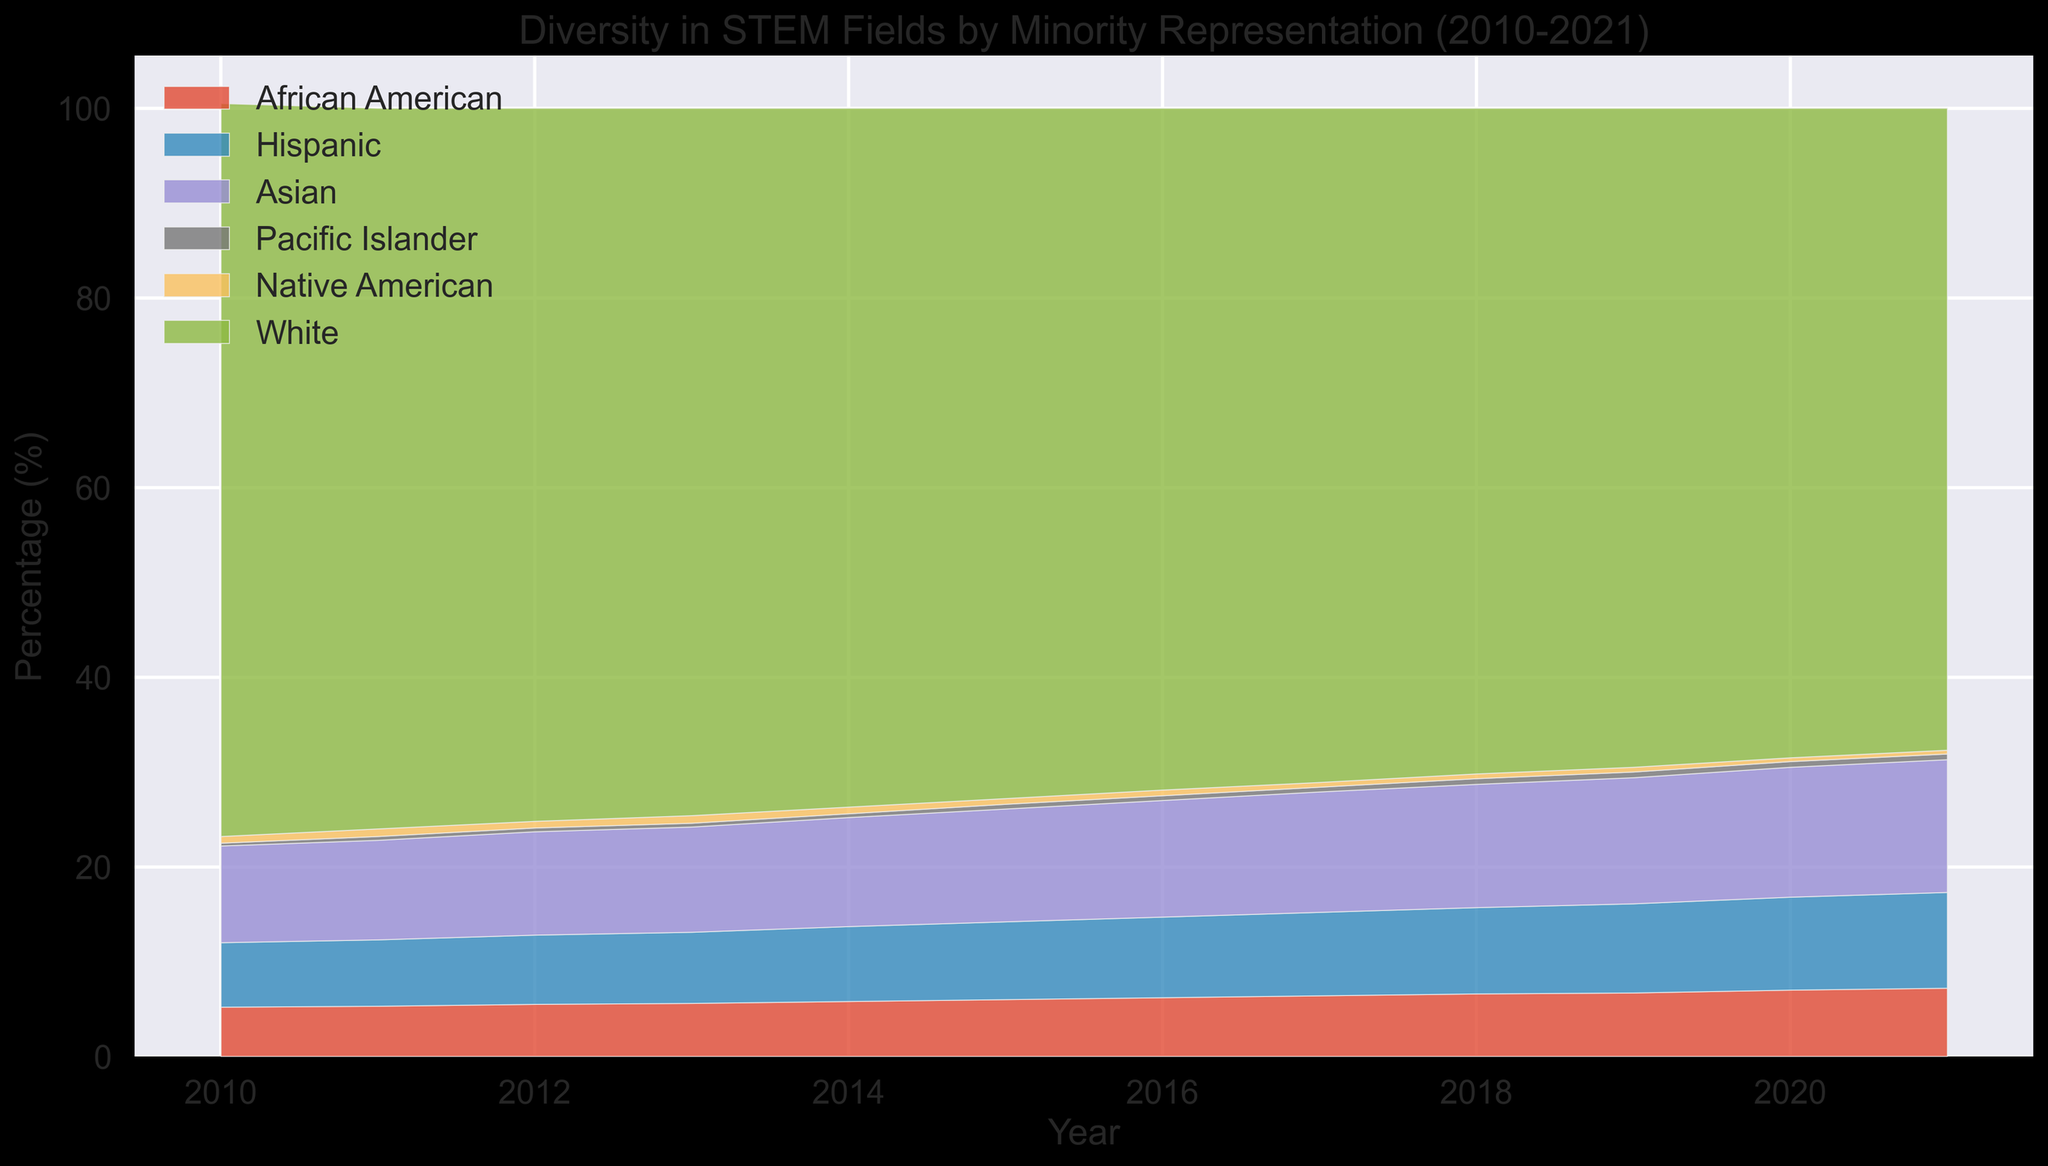What is the overall trend for the African American representation in STEM fields from 2010 to 2021? The area chart shows that the percentage of African Americans in STEM fields has increased steadily from 5.2% in 2010 to 7.2% in 2021. This is observed by the growing area in the chart representing African Americans.
Answer: The percentage increased Which group saw the highest increase in representation between 2010 and 2021? The areas representing different groups in the chart should be compared. Hispanics increased from 6.8% in 2010 to 10.1% in 2021, Asian from 10.2% to 14.0%, and African American from 5.2% to 7.2%. The Hispanic group saw an increase of 3.3 percentage points, which is the highest.
Answer: Hispanics By how much did the White representation decrease from 2010 to 2021? In 2010, the representation of Whites was 77.3%, and in 2021 it was 67.7%. Subtracting these values gives 77.3% - 67.7% = 9.6%.
Answer: 9.6% What is the combined representation of Pacific Islanders and Native Americans in 2015? The area chart shows Pacific Islanders at around 0.5% and Native Americans at 0.6% in 2015. Adding them results in 0.5% + 0.6% = 1.1%.
Answer: 1.1% Which group had the smallest representation in 2019? By comparing all the colored areas under 2019, Pacific Islanders had the smallest area at 0.6%.
Answer: Pacific Islanders Did any group's representation remain constant across the years? Observing the trends in areas for all groups, no group's representation was completely constant; all showed some degree of fluctuation.
Answer: No By how much did the Hispanic representation change from 2010 to 2015? The area chart indicates that Hispanic representation was 6.8% in 2010 and 8.2% in 2015. Subtracting these values gives 8.2% - 6.8% = 1.4%.
Answer: 1.4% Which year had the highest total representation for minority groups combined? To find this, subtract the representation of Whites from 100% for each year. In 2021, minorities combined represented 100% - 67.7% = 32.3%, which appears the highest.
Answer: 2021 What visual trend can you observe in the Asian representation from 2010 to 2021? The area corresponding to Asians shows a steady increase from 10.2% in 2010 to 14.0% in 2021, indicating an upward trend.
Answer: Steady increase What is the difference in representation between the Asian and Hispanic groups in 2020? According to the chart, Asians were at 13.7%, and Hispanics at 9.8% in 2020. The difference is 13.7% - 9.8% = 3.9%.
Answer: 3.9% 